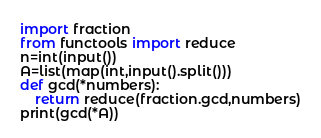<code> <loc_0><loc_0><loc_500><loc_500><_Python_>import fraction
from functools import reduce
n=int(input())
A=list(map(int,input().split()))
def gcd(*numbers):
    return reduce(fraction.gcd,numbers)
print(gcd(*A))
</code> 